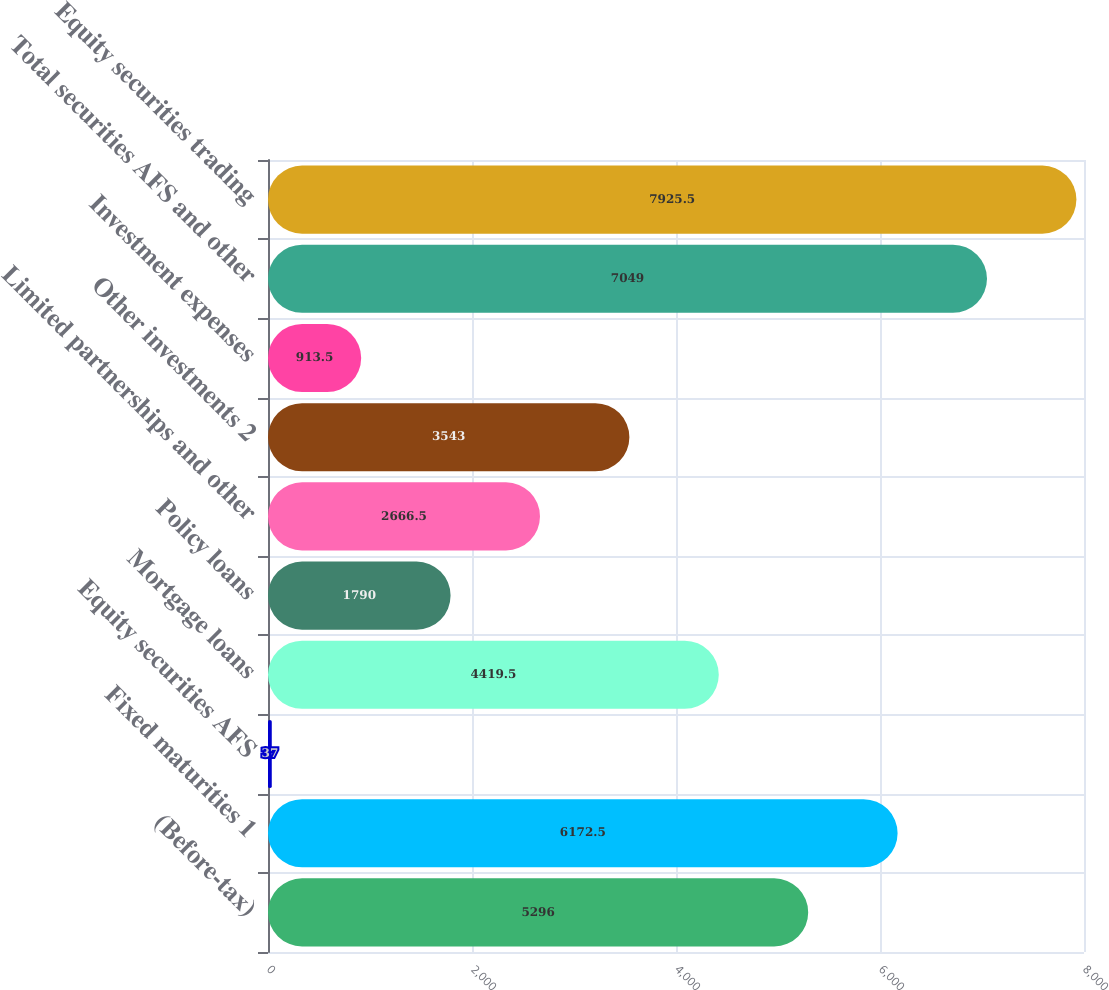<chart> <loc_0><loc_0><loc_500><loc_500><bar_chart><fcel>(Before-tax)<fcel>Fixed maturities 1<fcel>Equity securities AFS<fcel>Mortgage loans<fcel>Policy loans<fcel>Limited partnerships and other<fcel>Other investments 2<fcel>Investment expenses<fcel>Total securities AFS and other<fcel>Equity securities trading<nl><fcel>5296<fcel>6172.5<fcel>37<fcel>4419.5<fcel>1790<fcel>2666.5<fcel>3543<fcel>913.5<fcel>7049<fcel>7925.5<nl></chart> 